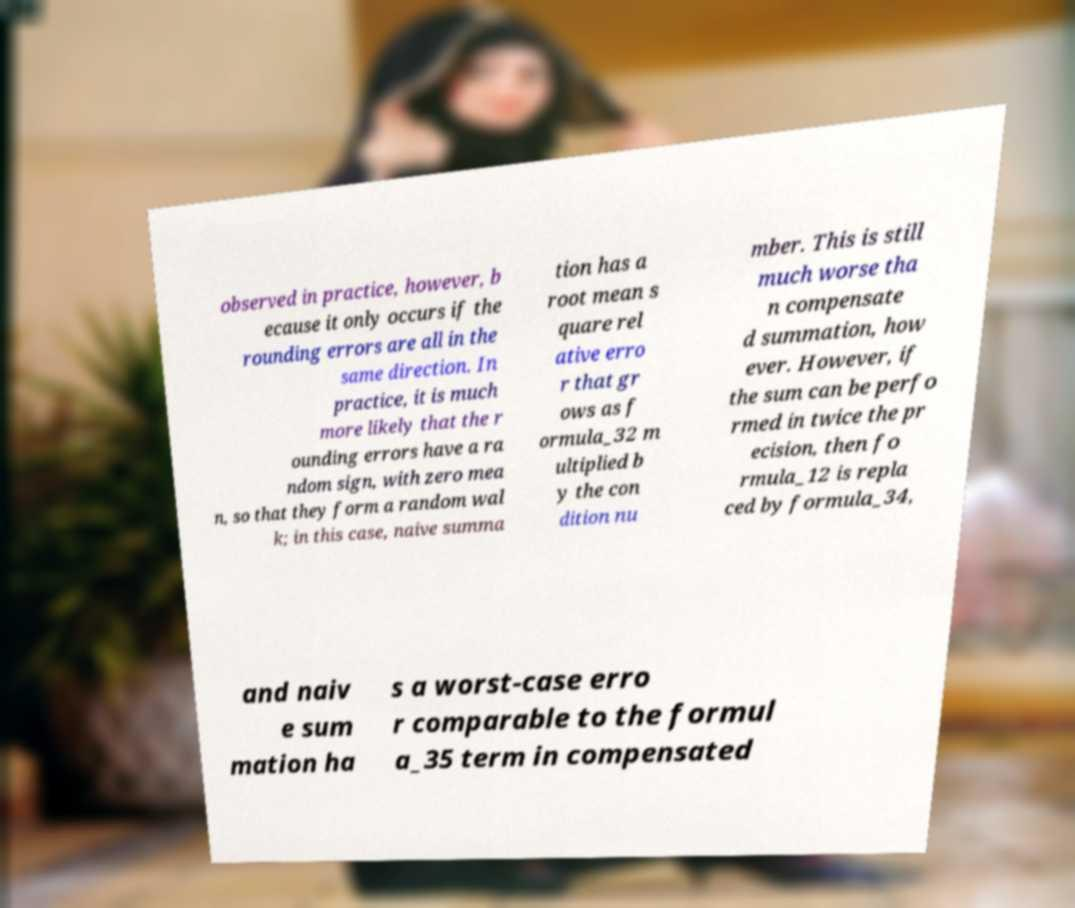There's text embedded in this image that I need extracted. Can you transcribe it verbatim? observed in practice, however, b ecause it only occurs if the rounding errors are all in the same direction. In practice, it is much more likely that the r ounding errors have a ra ndom sign, with zero mea n, so that they form a random wal k; in this case, naive summa tion has a root mean s quare rel ative erro r that gr ows as f ormula_32 m ultiplied b y the con dition nu mber. This is still much worse tha n compensate d summation, how ever. However, if the sum can be perfo rmed in twice the pr ecision, then fo rmula_12 is repla ced by formula_34, and naiv e sum mation ha s a worst-case erro r comparable to the formul a_35 term in compensated 